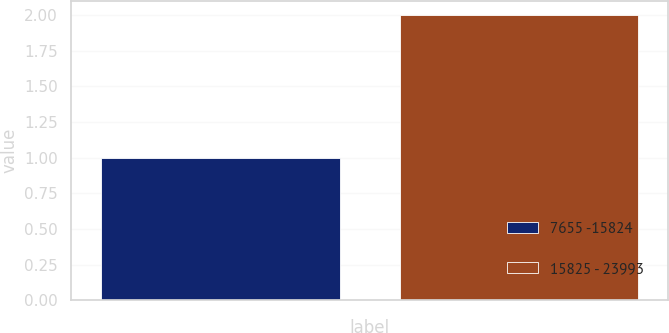Convert chart to OTSL. <chart><loc_0><loc_0><loc_500><loc_500><bar_chart><fcel>7655 -15824<fcel>15825 - 23993<nl><fcel>1<fcel>2<nl></chart> 